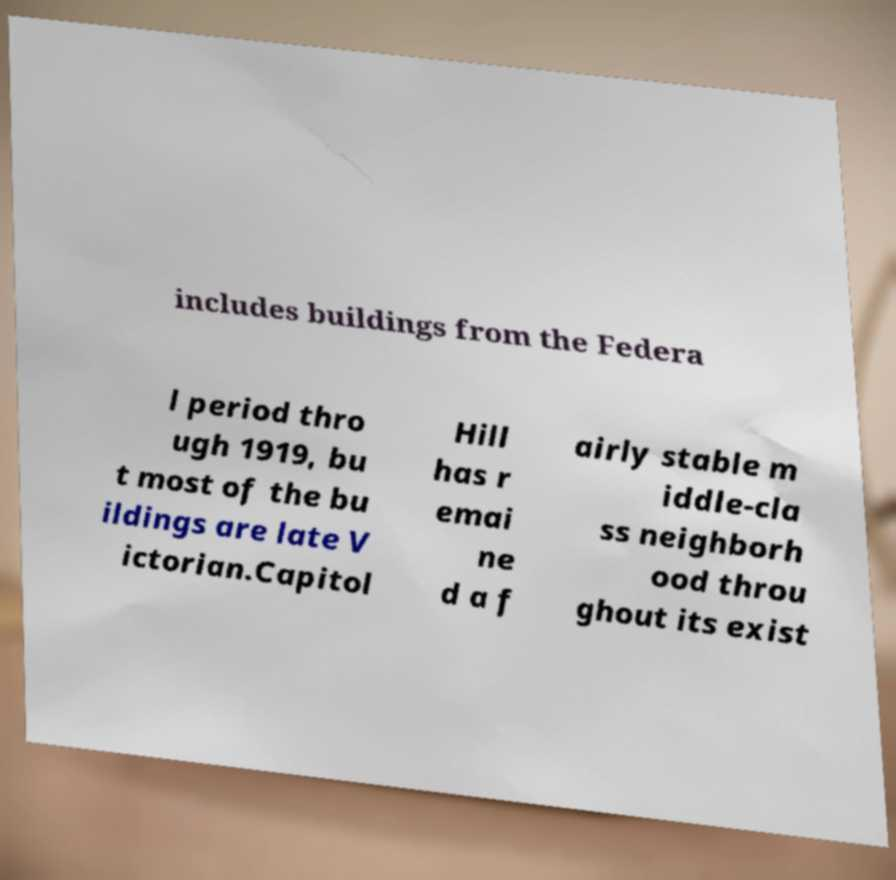Can you read and provide the text displayed in the image?This photo seems to have some interesting text. Can you extract and type it out for me? includes buildings from the Federa l period thro ugh 1919, bu t most of the bu ildings are late V ictorian.Capitol Hill has r emai ne d a f airly stable m iddle-cla ss neighborh ood throu ghout its exist 